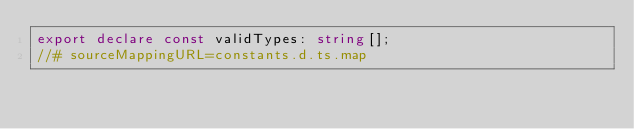Convert code to text. <code><loc_0><loc_0><loc_500><loc_500><_TypeScript_>export declare const validTypes: string[];
//# sourceMappingURL=constants.d.ts.map</code> 